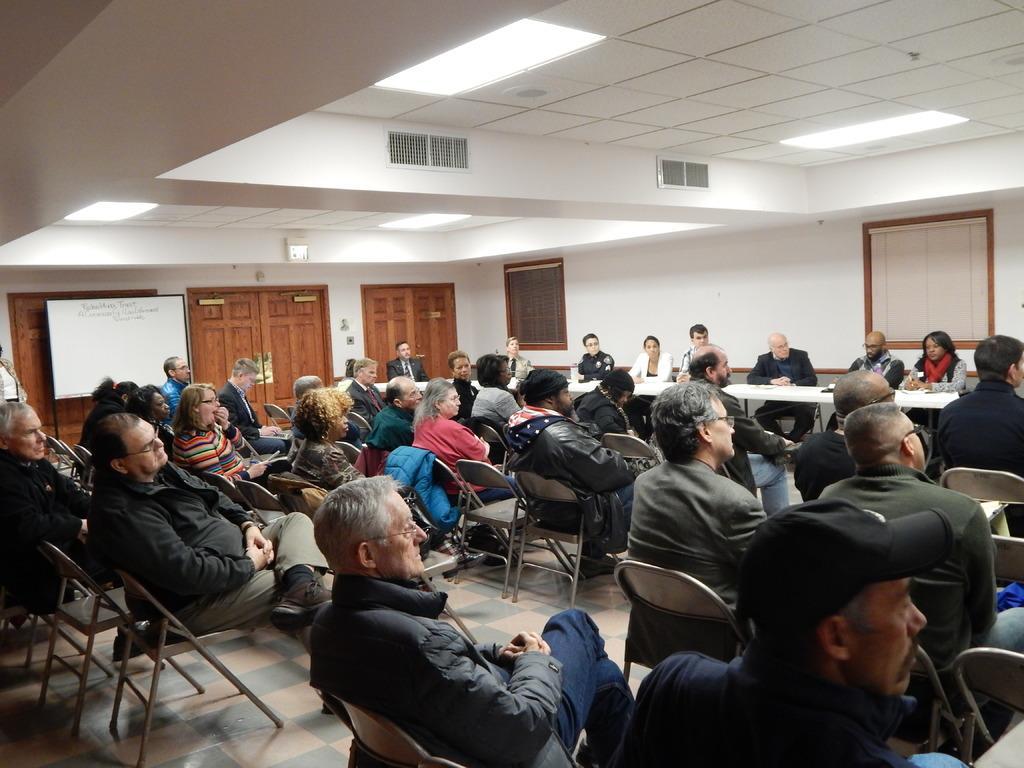How would you summarize this image in a sentence or two? In this picture I can observe some people sitting in the chairs. There are men and women in this picture. In the background I can observe a wall. 